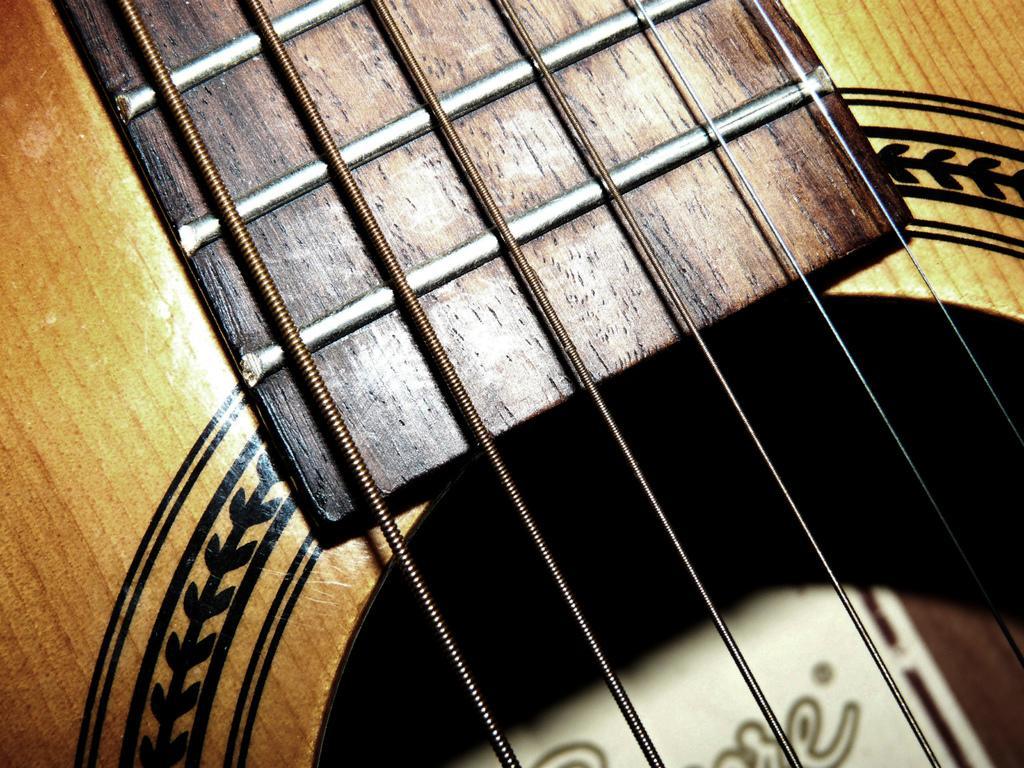Describe this image in one or two sentences. This is a musical instrument which has multiple strings. 